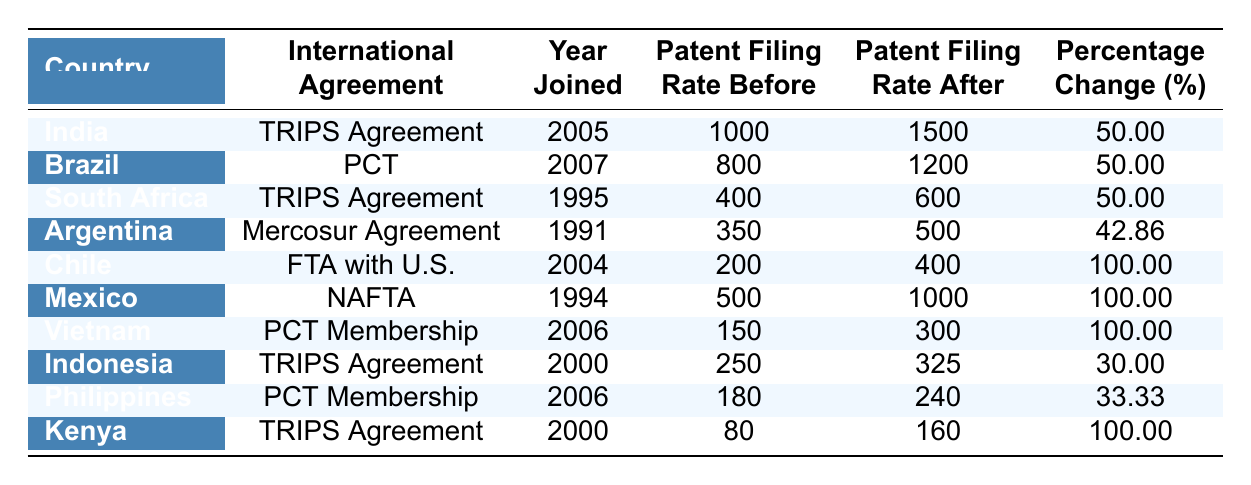What was the patent filing rate for Brazil before it joined the PCT? According to the table, Brazil's patent filing rate before joining the PCT was listed as 800.
Answer: 800 What is the percentage change in the patent filing rate for Kenya after joining the TRIPS Agreement? For Kenya, the patent filing rate after joining the TRIPS Agreement increased from 80 to 160, which reflects a percentage change of 100%.
Answer: 100 List the countries that experienced a patent filing rate increase of 100% after joining their respective international agreements. The countries that experienced a 100% increase in patent filing rates are Chile, Mexico, Vietnam, and Kenya.
Answer: Chile, Mexico, Vietnam, Kenya Which country had the lowest patent filing rate after joining an international agreement? The table shows that the country with the lowest patent filing rate after joining an international agreement is Vietnam, with a rate of 300.
Answer: Vietnam What is the average percentage change in patent filing rates for countries that joined the TRIPS Agreement? The countries that joined the TRIPS Agreement are India, South Africa, Indonesia, and Kenya. Their percentage changes are 50%, 50%, 30%, and 100%, respectively. The average is calculated as (50 + 50 + 30 + 100) / 4 = 57.5%.
Answer: 57.5 Which international agreement has the highest average patent filing rate change among the countries listed? To find the average, we calculate the percentage changes for the relevant agreements: TRIPS Agreement (57.5%), PCT (66.67%), Mercosur Agreement (42.86%), Free Trade Agreement with the U.S. (100%), and NAFTA (100%). The highest averages from the TRIPS and PCT are lower than the 100% average for both FTA with U.S. and NAFTA, so these two have the highest rate.
Answer: Free Trade Agreement with the U.S. and NAFTA Is the patent filing rate after joining an agreement higher than the rate before for all countries in the table? By examining each row, we find that all countries listed in the table show an increase in their patent filing rates after joining an international agreement. Therefore, the answer is true.
Answer: Yes What is the difference in patent filing rates for Argentina before and after joining the Mercosur Agreement? The difference can be calculated by subtracting the patent filing rate before (350) from the rate after (500). This gives us 500 - 350 = 150.
Answer: 150 